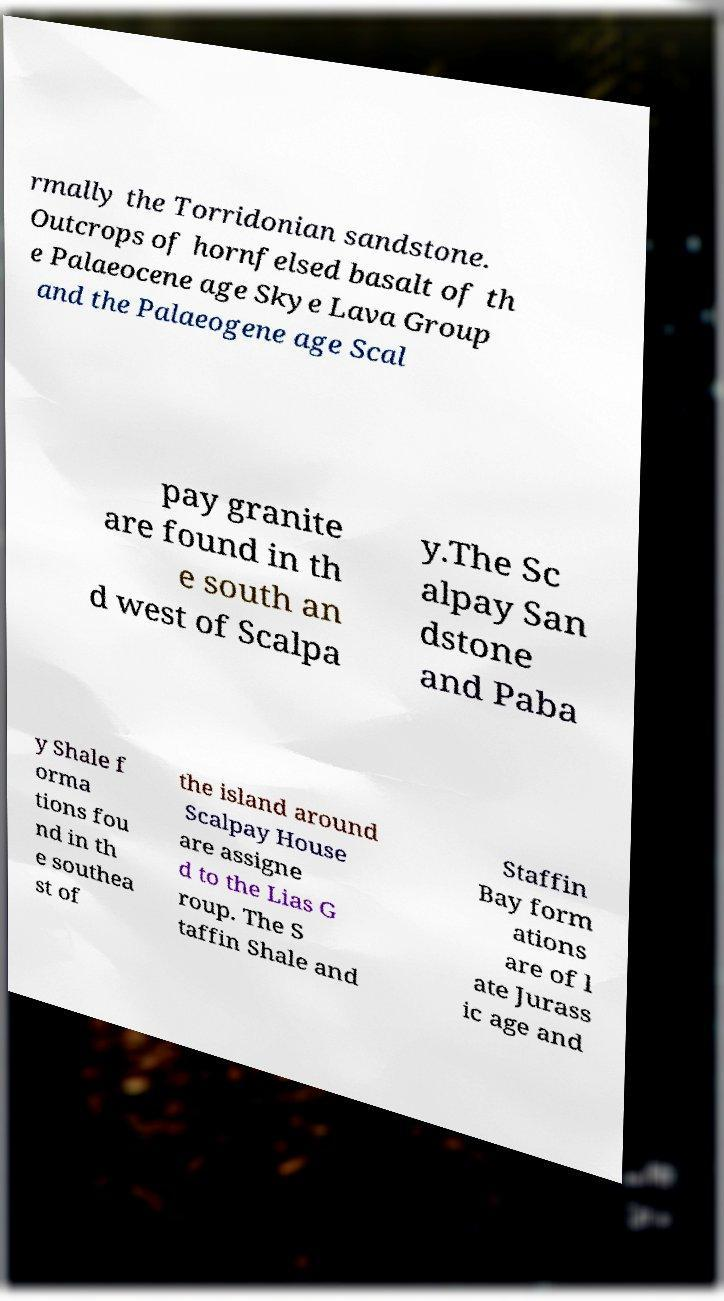Can you accurately transcribe the text from the provided image for me? rmally the Torridonian sandstone. Outcrops of hornfelsed basalt of th e Palaeocene age Skye Lava Group and the Palaeogene age Scal pay granite are found in th e south an d west of Scalpa y.The Sc alpay San dstone and Paba y Shale f orma tions fou nd in th e southea st of the island around Scalpay House are assigne d to the Lias G roup. The S taffin Shale and Staffin Bay form ations are of l ate Jurass ic age and 